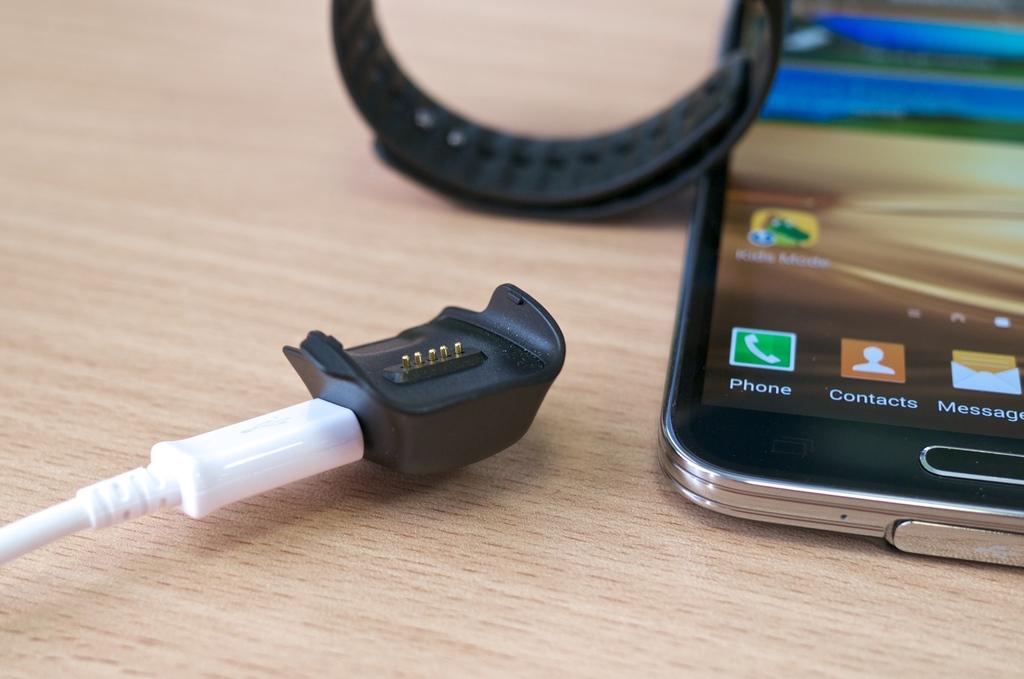Where is the "phone" button located?
Ensure brevity in your answer.  Bottom left. 